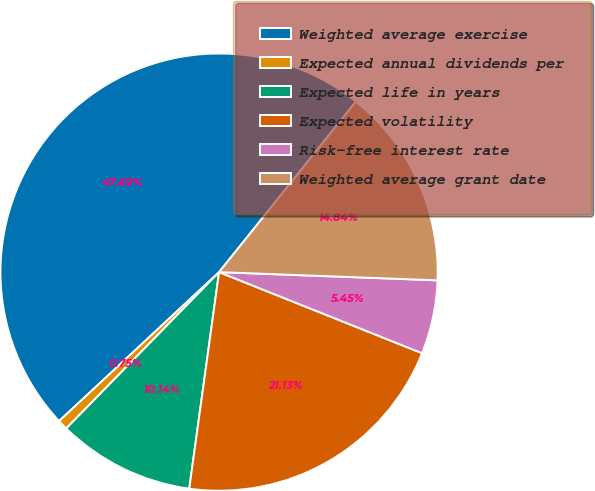Convert chart to OTSL. <chart><loc_0><loc_0><loc_500><loc_500><pie_chart><fcel>Weighted average exercise<fcel>Expected annual dividends per<fcel>Expected life in years<fcel>Expected volatility<fcel>Risk-free interest rate<fcel>Weighted average grant date<nl><fcel>47.69%<fcel>0.75%<fcel>10.14%<fcel>21.13%<fcel>5.45%<fcel>14.84%<nl></chart> 